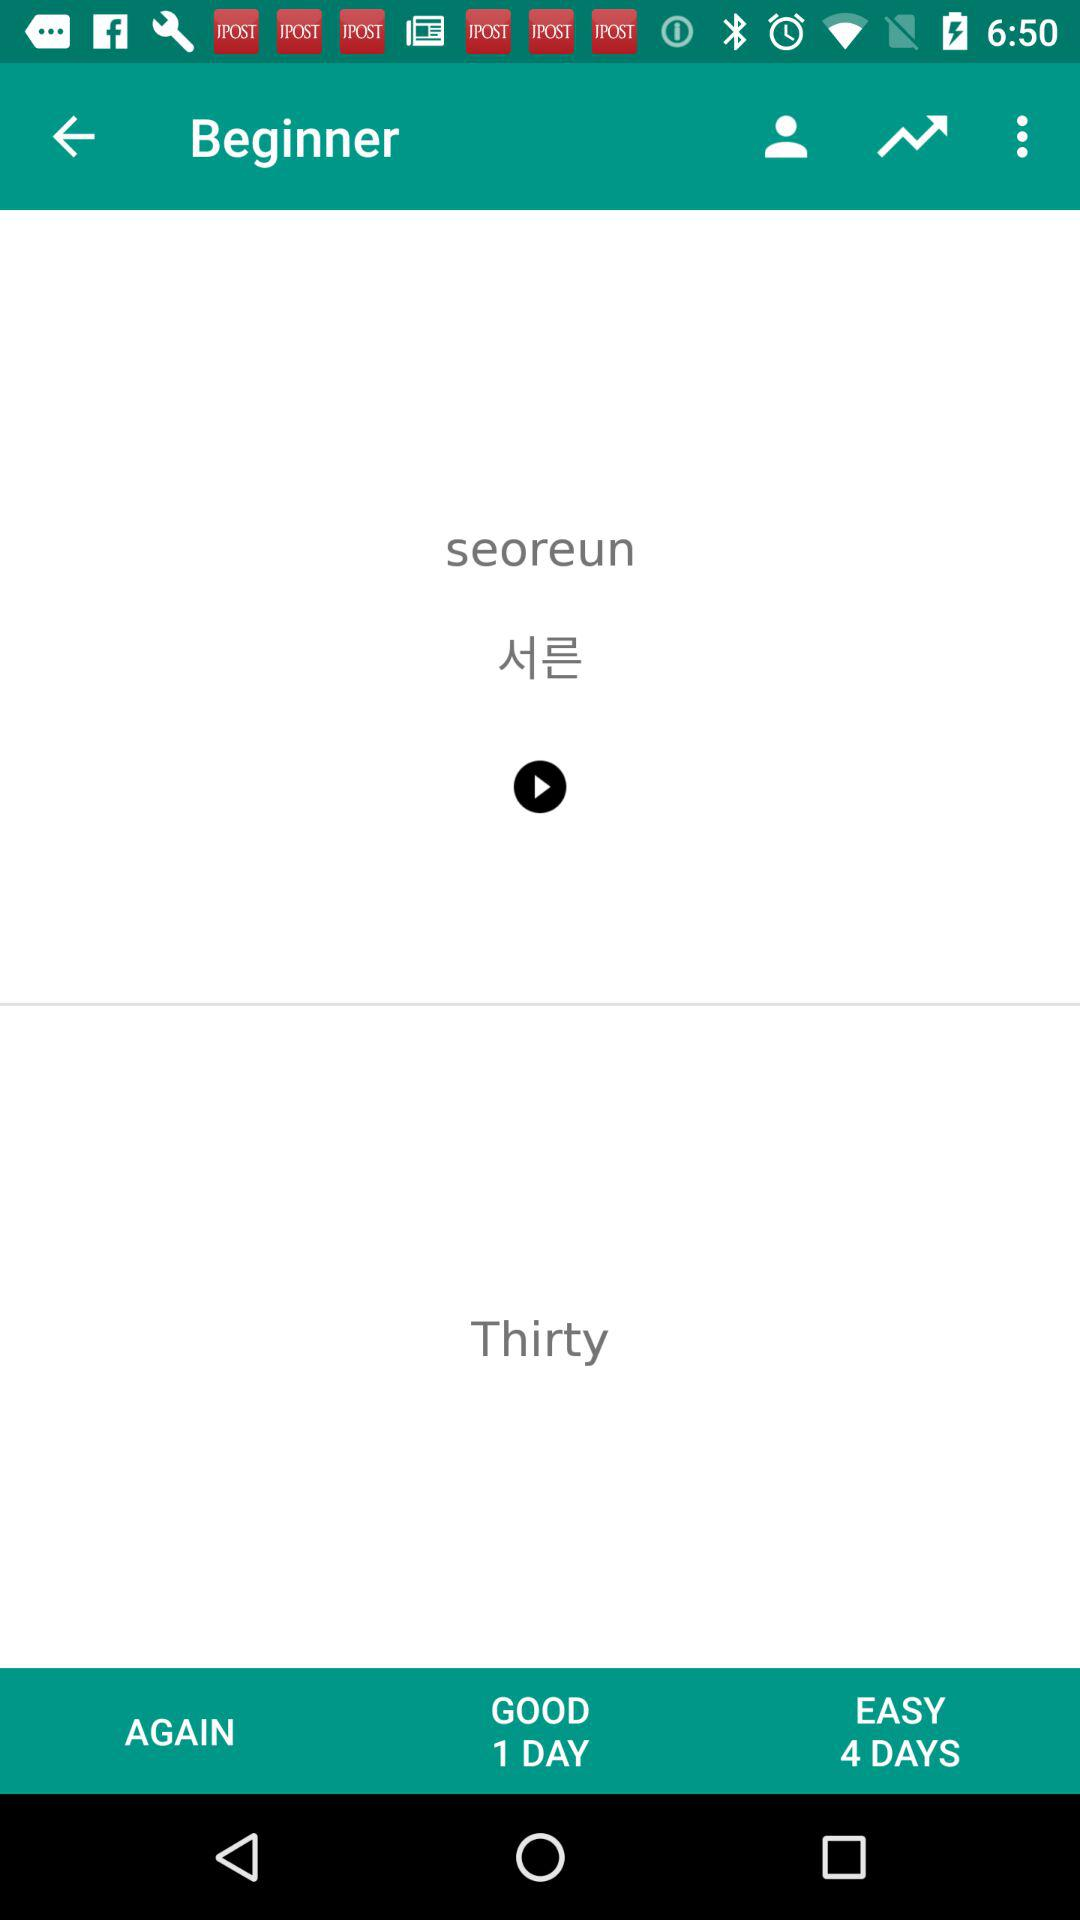How many more days does the easy difficulty require than the good difficulty?
Answer the question using a single word or phrase. 3 